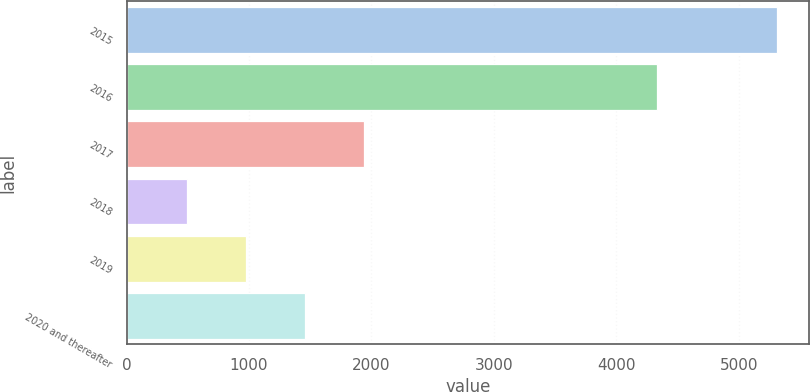Convert chart to OTSL. <chart><loc_0><loc_0><loc_500><loc_500><bar_chart><fcel>2015<fcel>2016<fcel>2017<fcel>2018<fcel>2019<fcel>2020 and thereafter<nl><fcel>5310<fcel>4329<fcel>1939.5<fcel>495<fcel>976.5<fcel>1458<nl></chart> 